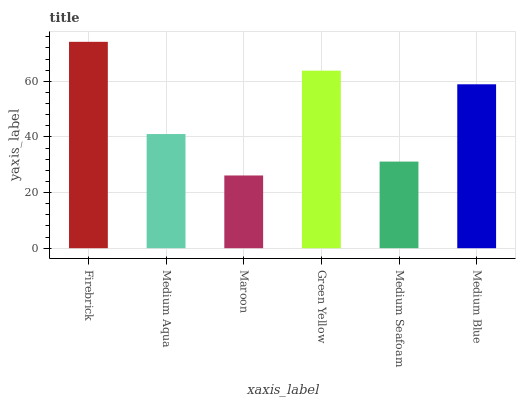Is Medium Aqua the minimum?
Answer yes or no. No. Is Medium Aqua the maximum?
Answer yes or no. No. Is Firebrick greater than Medium Aqua?
Answer yes or no. Yes. Is Medium Aqua less than Firebrick?
Answer yes or no. Yes. Is Medium Aqua greater than Firebrick?
Answer yes or no. No. Is Firebrick less than Medium Aqua?
Answer yes or no. No. Is Medium Blue the high median?
Answer yes or no. Yes. Is Medium Aqua the low median?
Answer yes or no. Yes. Is Medium Seafoam the high median?
Answer yes or no. No. Is Medium Seafoam the low median?
Answer yes or no. No. 